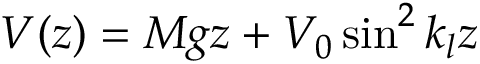<formula> <loc_0><loc_0><loc_500><loc_500>V ( z ) = M g z + V _ { 0 } \sin ^ { 2 } k _ { l } z</formula> 